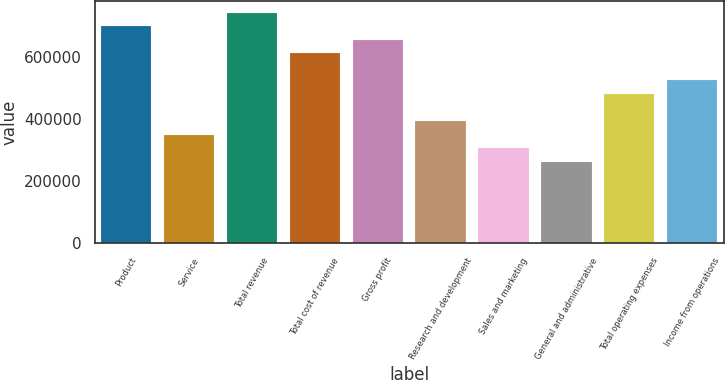Convert chart. <chart><loc_0><loc_0><loc_500><loc_500><bar_chart><fcel>Product<fcel>Service<fcel>Total revenue<fcel>Total cost of revenue<fcel>Gross profit<fcel>Research and development<fcel>Sales and marketing<fcel>General and administrative<fcel>Total operating expenses<fcel>Income from operations<nl><fcel>700212<fcel>350107<fcel>743975<fcel>612686<fcel>656449<fcel>393870<fcel>306344<fcel>262580<fcel>481396<fcel>525159<nl></chart> 